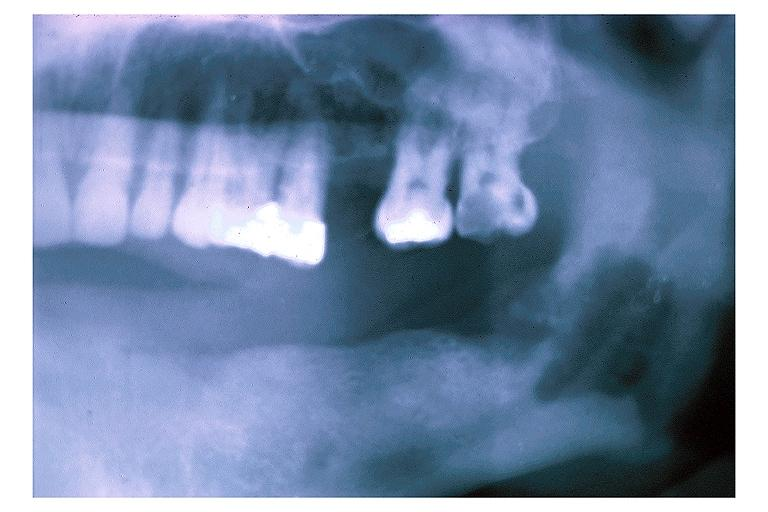where is this?
Answer the question using a single word or phrase. Oral 